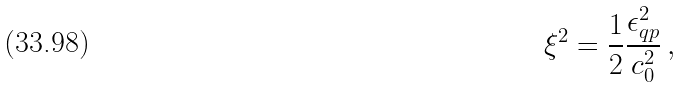<formula> <loc_0><loc_0><loc_500><loc_500>\xi ^ { 2 } = \frac { 1 } { 2 } \frac { \epsilon _ { q p } ^ { 2 } } { c _ { 0 } ^ { 2 } } \, ,</formula> 